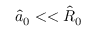<formula> <loc_0><loc_0><loc_500><loc_500>\hat { a } _ { 0 } < < \hat { R } _ { 0 }</formula> 